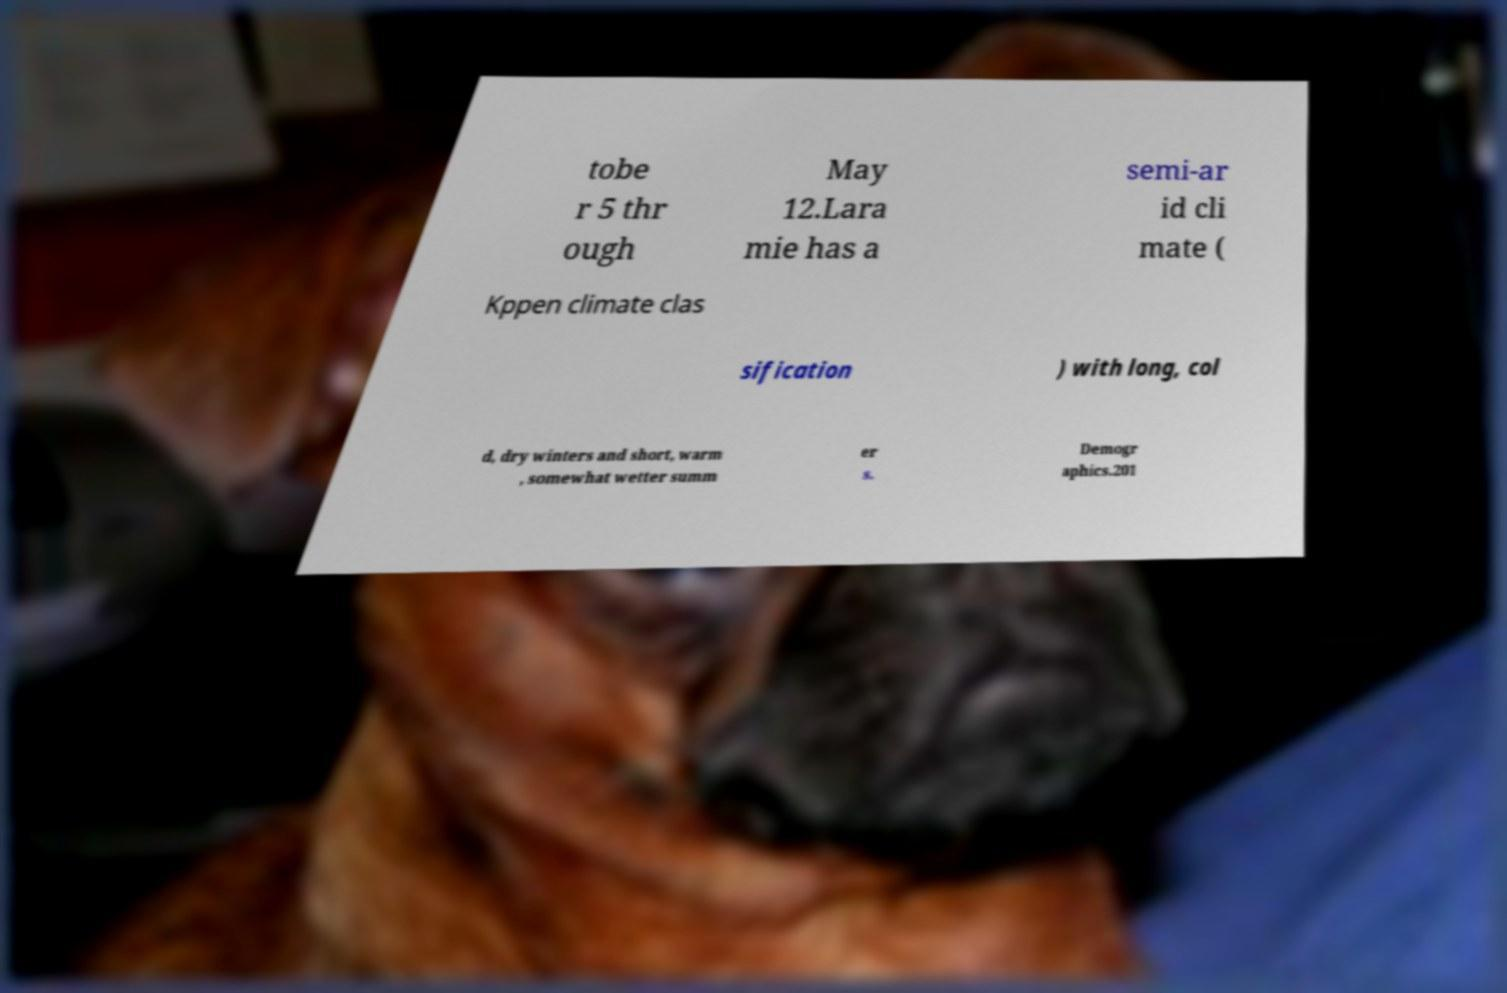For documentation purposes, I need the text within this image transcribed. Could you provide that? tobe r 5 thr ough May 12.Lara mie has a semi-ar id cli mate ( Kppen climate clas sification ) with long, col d, dry winters and short, warm , somewhat wetter summ er s. Demogr aphics.201 